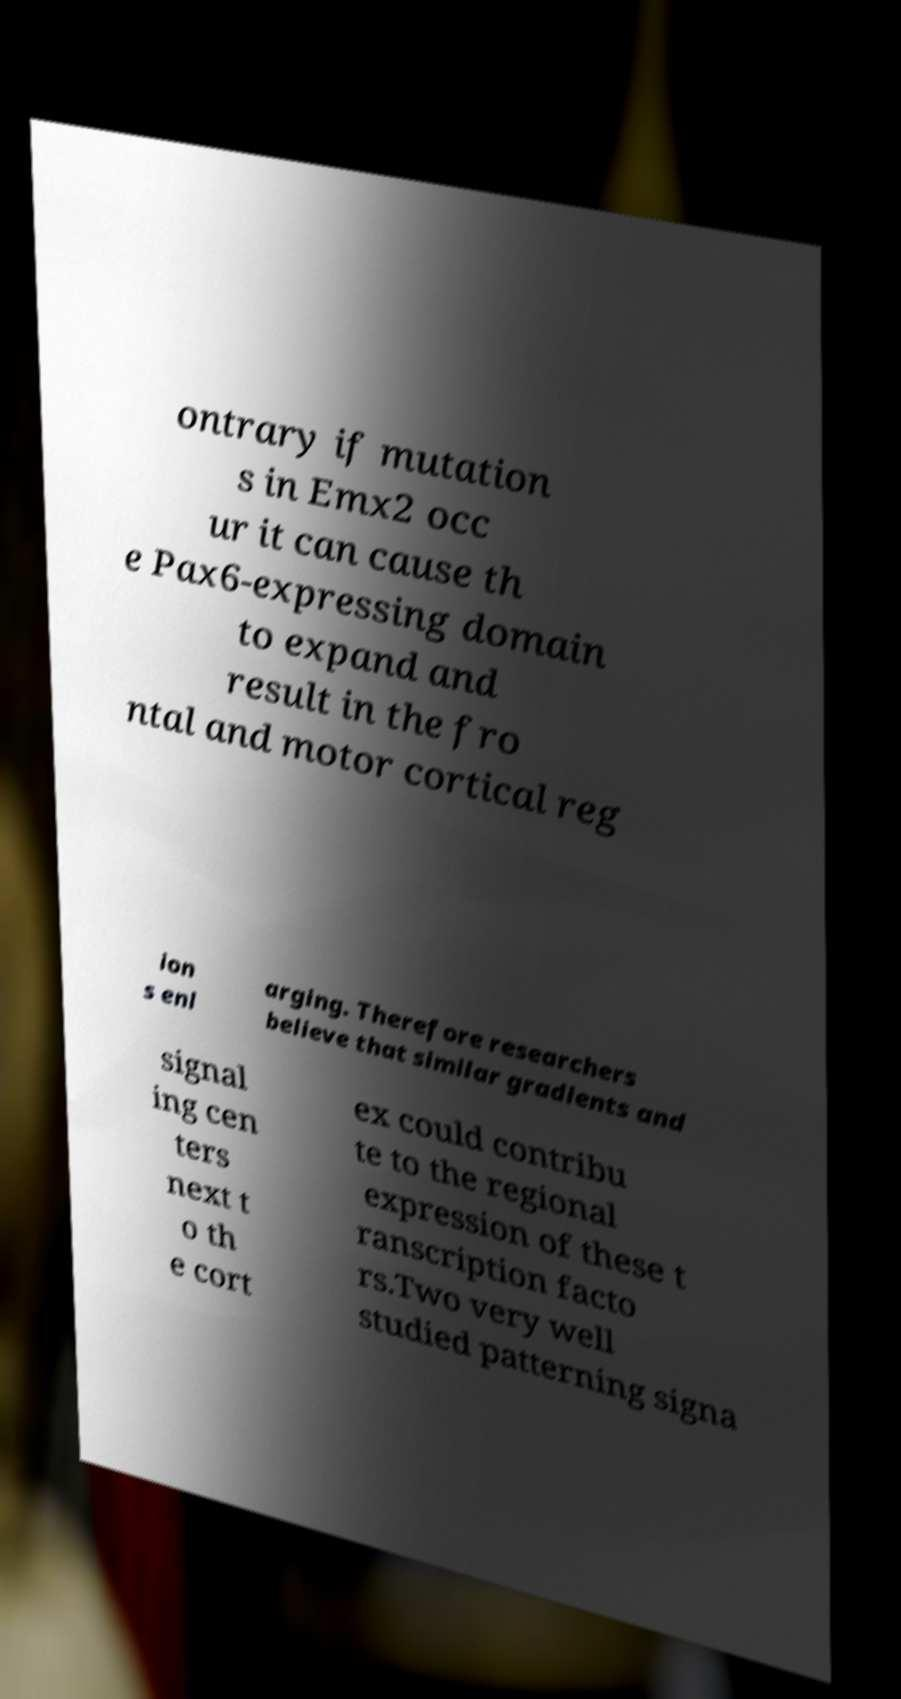I need the written content from this picture converted into text. Can you do that? ontrary if mutation s in Emx2 occ ur it can cause th e Pax6-expressing domain to expand and result in the fro ntal and motor cortical reg ion s enl arging. Therefore researchers believe that similar gradients and signal ing cen ters next t o th e cort ex could contribu te to the regional expression of these t ranscription facto rs.Two very well studied patterning signa 